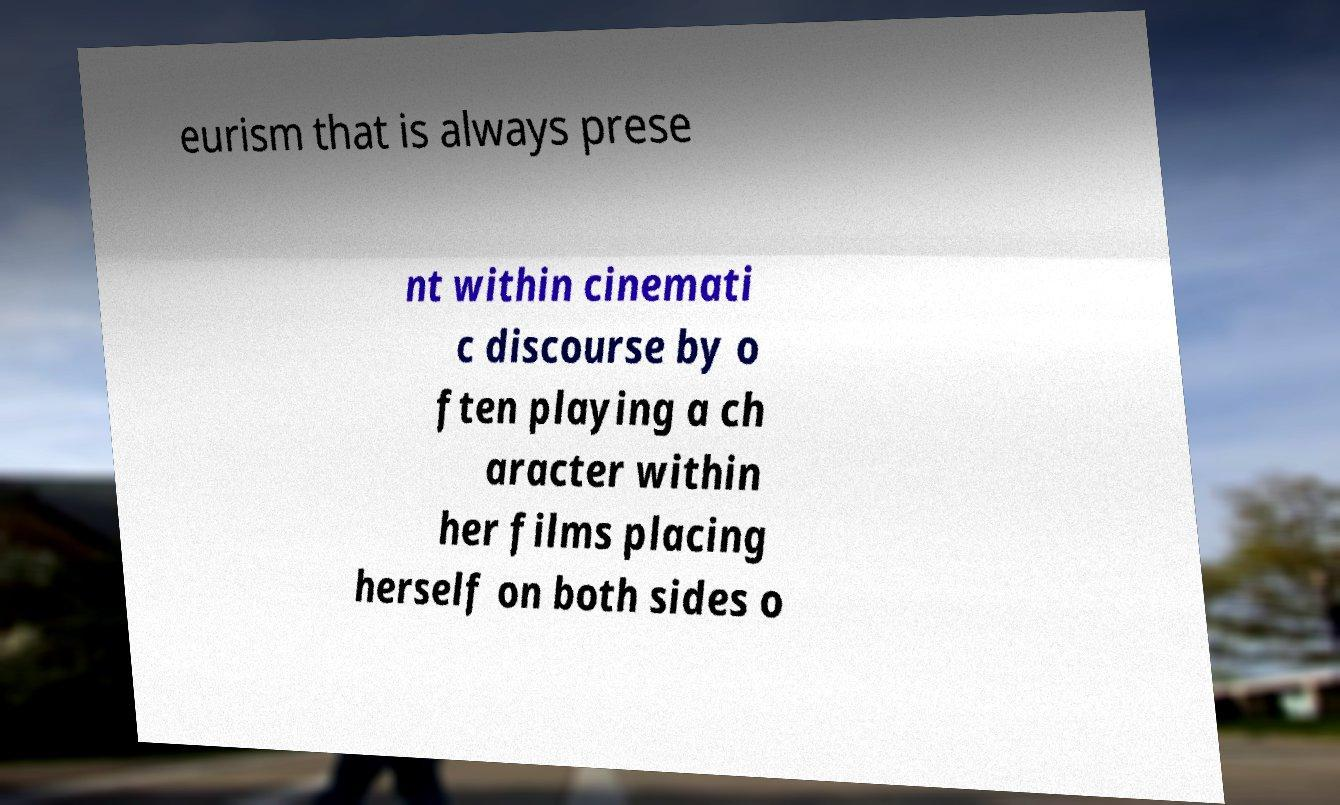Can you accurately transcribe the text from the provided image for me? eurism that is always prese nt within cinemati c discourse by o ften playing a ch aracter within her films placing herself on both sides o 